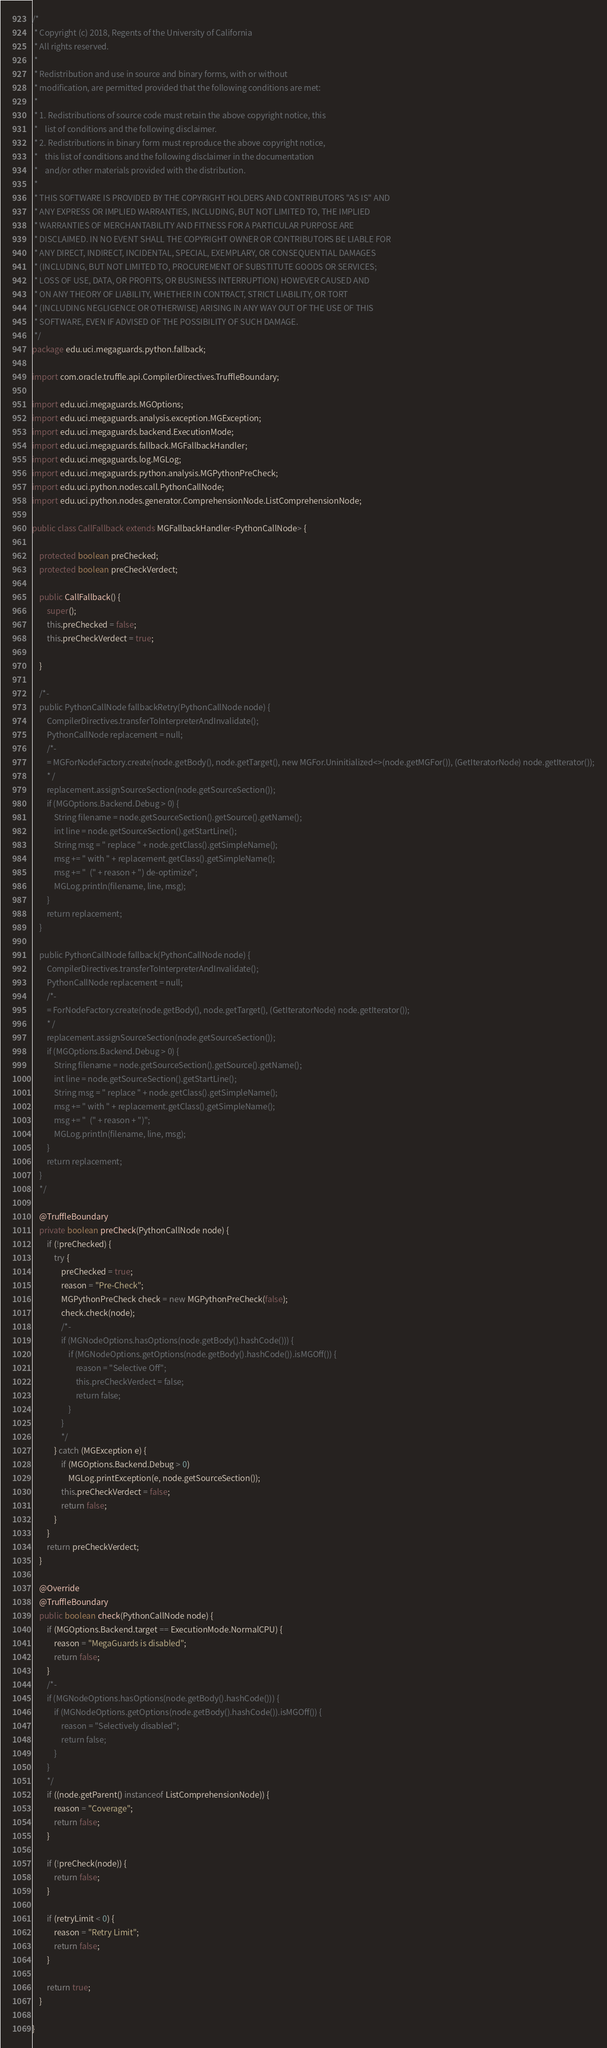Convert code to text. <code><loc_0><loc_0><loc_500><loc_500><_Java_>/*
 * Copyright (c) 2018, Regents of the University of California
 * All rights reserved.
 *
 * Redistribution and use in source and binary forms, with or without
 * modification, are permitted provided that the following conditions are met:
 *
 * 1. Redistributions of source code must retain the above copyright notice, this
 *    list of conditions and the following disclaimer.
 * 2. Redistributions in binary form must reproduce the above copyright notice,
 *    this list of conditions and the following disclaimer in the documentation
 *    and/or other materials provided with the distribution.
 *
 * THIS SOFTWARE IS PROVIDED BY THE COPYRIGHT HOLDERS AND CONTRIBUTORS "AS IS" AND
 * ANY EXPRESS OR IMPLIED WARRANTIES, INCLUDING, BUT NOT LIMITED TO, THE IMPLIED
 * WARRANTIES OF MERCHANTABILITY AND FITNESS FOR A PARTICULAR PURPOSE ARE
 * DISCLAIMED. IN NO EVENT SHALL THE COPYRIGHT OWNER OR CONTRIBUTORS BE LIABLE FOR
 * ANY DIRECT, INDIRECT, INCIDENTAL, SPECIAL, EXEMPLARY, OR CONSEQUENTIAL DAMAGES
 * (INCLUDING, BUT NOT LIMITED TO, PROCUREMENT OF SUBSTITUTE GOODS OR SERVICES;
 * LOSS OF USE, DATA, OR PROFITS; OR BUSINESS INTERRUPTION) HOWEVER CAUSED AND
 * ON ANY THEORY OF LIABILITY, WHETHER IN CONTRACT, STRICT LIABILITY, OR TORT
 * (INCLUDING NEGLIGENCE OR OTHERWISE) ARISING IN ANY WAY OUT OF THE USE OF THIS
 * SOFTWARE, EVEN IF ADVISED OF THE POSSIBILITY OF SUCH DAMAGE.
 */
package edu.uci.megaguards.python.fallback;

import com.oracle.truffle.api.CompilerDirectives.TruffleBoundary;

import edu.uci.megaguards.MGOptions;
import edu.uci.megaguards.analysis.exception.MGException;
import edu.uci.megaguards.backend.ExecutionMode;
import edu.uci.megaguards.fallback.MGFallbackHandler;
import edu.uci.megaguards.log.MGLog;
import edu.uci.megaguards.python.analysis.MGPythonPreCheck;
import edu.uci.python.nodes.call.PythonCallNode;
import edu.uci.python.nodes.generator.ComprehensionNode.ListComprehensionNode;

public class CallFallback extends MGFallbackHandler<PythonCallNode> {

    protected boolean preChecked;
    protected boolean preCheckVerdect;

    public CallFallback() {
        super();
        this.preChecked = false;
        this.preCheckVerdect = true;

    }

    /*-
    public PythonCallNode fallbackRetry(PythonCallNode node) {
        CompilerDirectives.transferToInterpreterAndInvalidate();
        PythonCallNode replacement = null;
        /*-
        = MGForNodeFactory.create(node.getBody(), node.getTarget(), new MGFor.Uninitialized<>(node.getMGFor()), (GetIteratorNode) node.getIterator());
        * /
        replacement.assignSourceSection(node.getSourceSection());
        if (MGOptions.Backend.Debug > 0) {
            String filename = node.getSourceSection().getSource().getName();
            int line = node.getSourceSection().getStartLine();
            String msg = " replace " + node.getClass().getSimpleName();
            msg += " with " + replacement.getClass().getSimpleName();
            msg += "  (" + reason + ") de-optimize";
            MGLog.println(filename, line, msg);
        }
        return replacement;
    }

    public PythonCallNode fallback(PythonCallNode node) {
        CompilerDirectives.transferToInterpreterAndInvalidate();
        PythonCallNode replacement = null;
        /*-
        = ForNodeFactory.create(node.getBody(), node.getTarget(), (GetIteratorNode) node.getIterator());
        * /
        replacement.assignSourceSection(node.getSourceSection());
        if (MGOptions.Backend.Debug > 0) {
            String filename = node.getSourceSection().getSource().getName();
            int line = node.getSourceSection().getStartLine();
            String msg = " replace " + node.getClass().getSimpleName();
            msg += " with " + replacement.getClass().getSimpleName();
            msg += "  (" + reason + ")";
            MGLog.println(filename, line, msg);
        }
        return replacement;
    }
    */

    @TruffleBoundary
    private boolean preCheck(PythonCallNode node) {
        if (!preChecked) {
            try {
                preChecked = true;
                reason = "Pre-Check";
                MGPythonPreCheck check = new MGPythonPreCheck(false);
                check.check(node);
                /*-
                if (MGNodeOptions.hasOptions(node.getBody().hashCode())) {
                    if (MGNodeOptions.getOptions(node.getBody().hashCode()).isMGOff()) {
                        reason = "Selective Off";
                        this.preCheckVerdect = false;
                        return false;
                    }
                }
                */
            } catch (MGException e) {
                if (MGOptions.Backend.Debug > 0)
                    MGLog.printException(e, node.getSourceSection());
                this.preCheckVerdect = false;
                return false;
            }
        }
        return preCheckVerdect;
    }

    @Override
    @TruffleBoundary
    public boolean check(PythonCallNode node) {
        if (MGOptions.Backend.target == ExecutionMode.NormalCPU) {
            reason = "MegaGuards is disabled";
            return false;
        }
        /*-
        if (MGNodeOptions.hasOptions(node.getBody().hashCode())) {
            if (MGNodeOptions.getOptions(node.getBody().hashCode()).isMGOff()) {
                reason = "Selectively disabled";
                return false;
            }
        }
        */
        if ((node.getParent() instanceof ListComprehensionNode)) {
            reason = "Coverage";
            return false;
        }

        if (!preCheck(node)) {
            return false;
        }

        if (retryLimit < 0) {
            reason = "Retry Limit";
            return false;
        }

        return true;
    }

}
</code> 